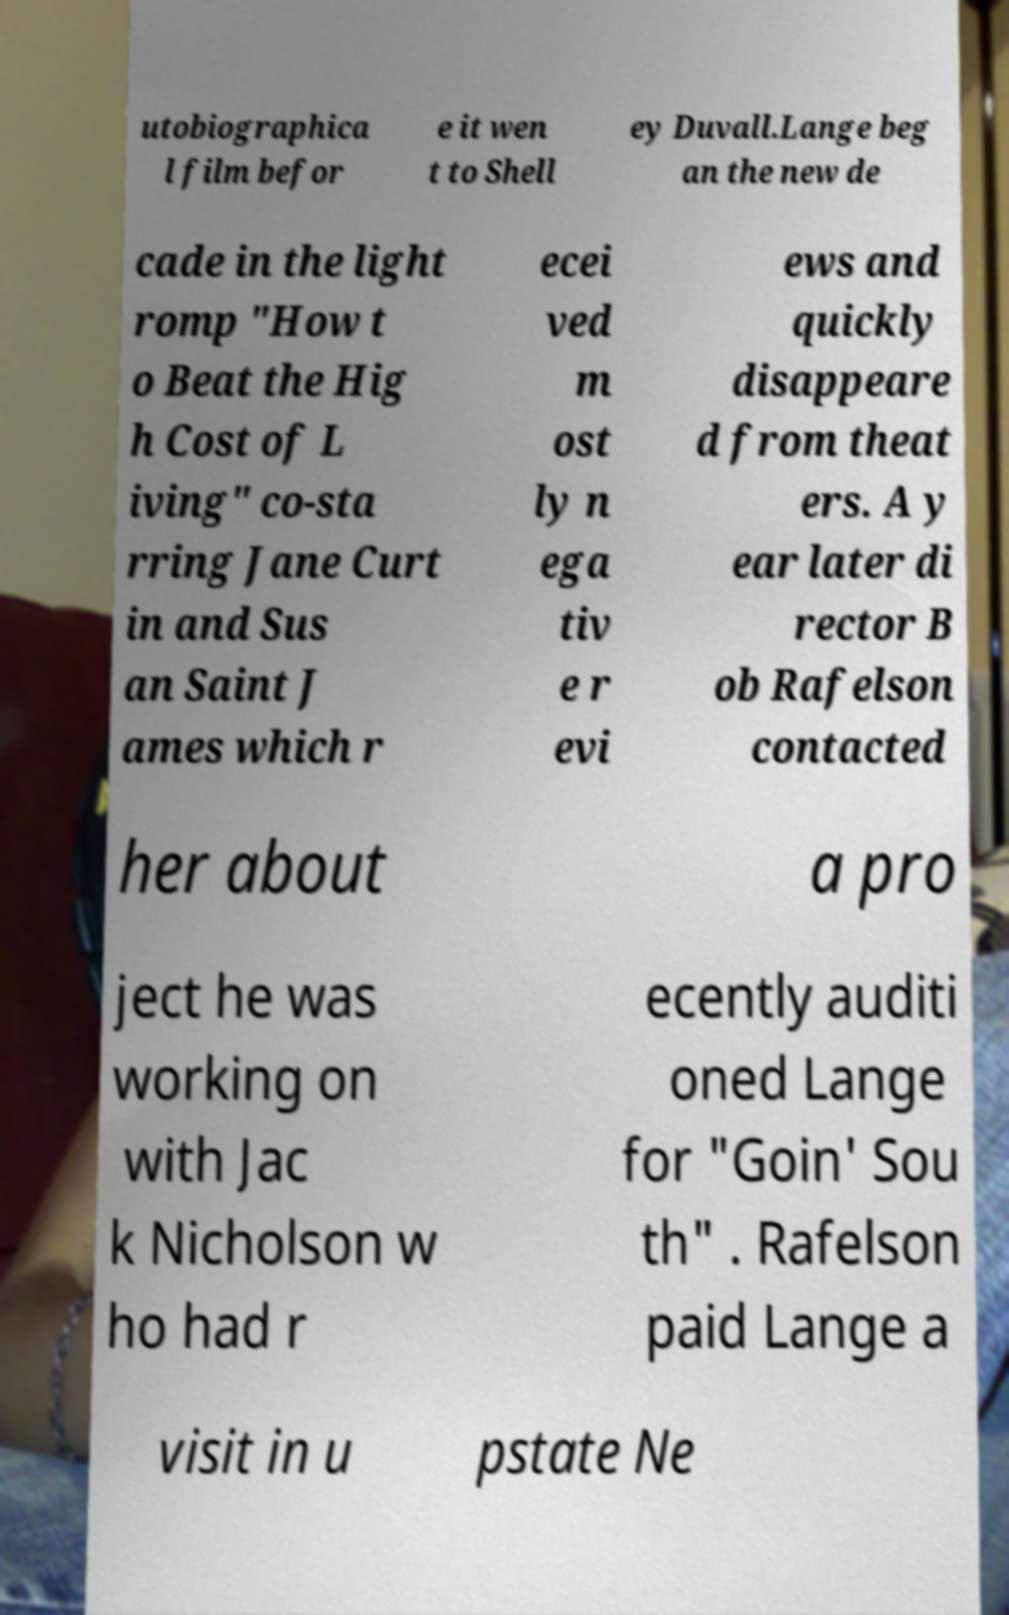What messages or text are displayed in this image? I need them in a readable, typed format. utobiographica l film befor e it wen t to Shell ey Duvall.Lange beg an the new de cade in the light romp "How t o Beat the Hig h Cost of L iving" co-sta rring Jane Curt in and Sus an Saint J ames which r ecei ved m ost ly n ega tiv e r evi ews and quickly disappeare d from theat ers. A y ear later di rector B ob Rafelson contacted her about a pro ject he was working on with Jac k Nicholson w ho had r ecently auditi oned Lange for "Goin' Sou th" . Rafelson paid Lange a visit in u pstate Ne 